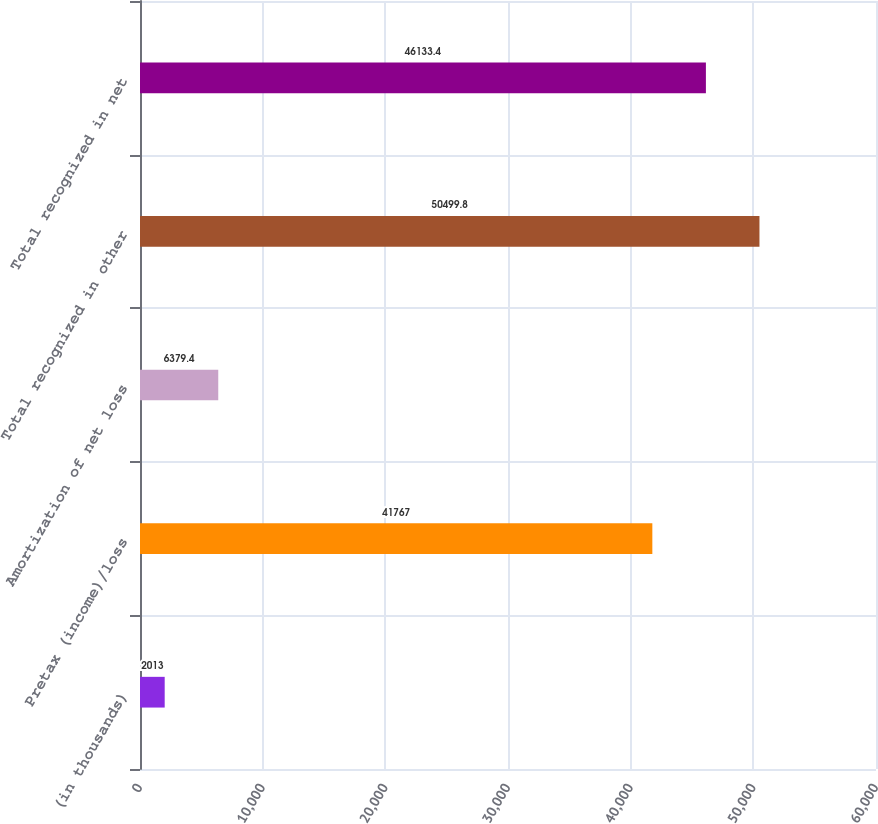<chart> <loc_0><loc_0><loc_500><loc_500><bar_chart><fcel>(in thousands)<fcel>Pretax (income)/loss<fcel>Amortization of net loss<fcel>Total recognized in other<fcel>Total recognized in net<nl><fcel>2013<fcel>41767<fcel>6379.4<fcel>50499.8<fcel>46133.4<nl></chart> 